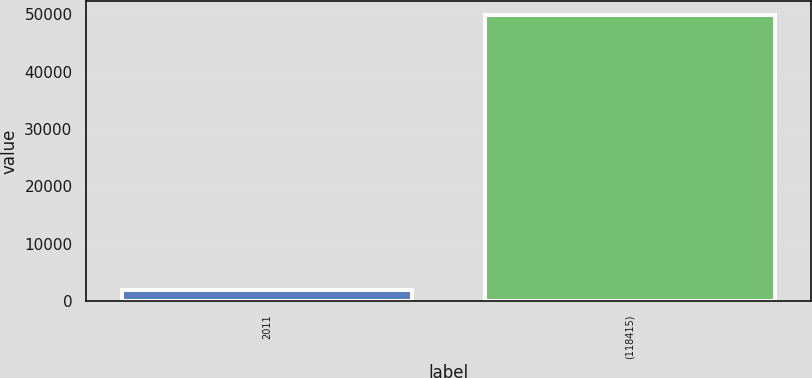Convert chart to OTSL. <chart><loc_0><loc_0><loc_500><loc_500><bar_chart><fcel>2011<fcel>(118415)<nl><fcel>2010<fcel>49887<nl></chart> 